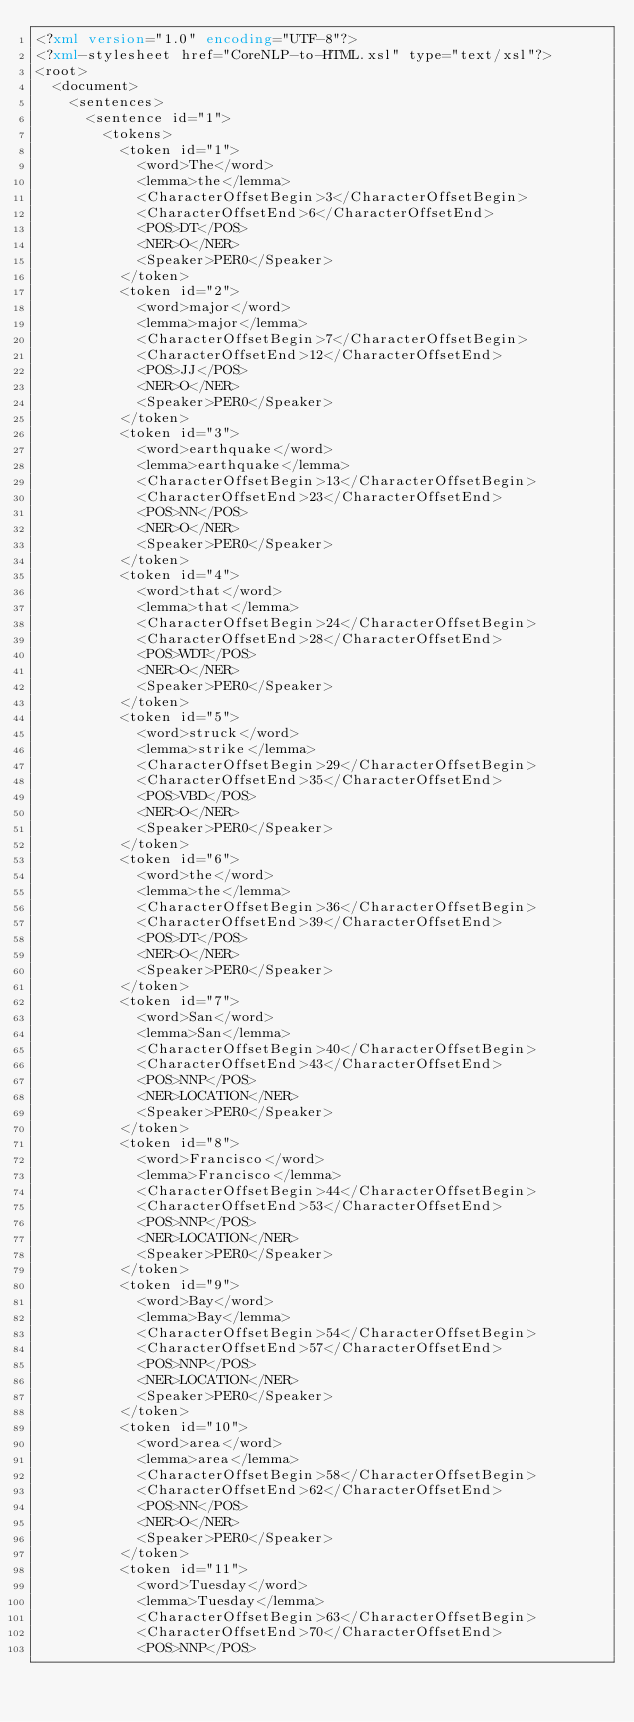<code> <loc_0><loc_0><loc_500><loc_500><_XML_><?xml version="1.0" encoding="UTF-8"?>
<?xml-stylesheet href="CoreNLP-to-HTML.xsl" type="text/xsl"?>
<root>
  <document>
    <sentences>
      <sentence id="1">
        <tokens>
          <token id="1">
            <word>The</word>
            <lemma>the</lemma>
            <CharacterOffsetBegin>3</CharacterOffsetBegin>
            <CharacterOffsetEnd>6</CharacterOffsetEnd>
            <POS>DT</POS>
            <NER>O</NER>
            <Speaker>PER0</Speaker>
          </token>
          <token id="2">
            <word>major</word>
            <lemma>major</lemma>
            <CharacterOffsetBegin>7</CharacterOffsetBegin>
            <CharacterOffsetEnd>12</CharacterOffsetEnd>
            <POS>JJ</POS>
            <NER>O</NER>
            <Speaker>PER0</Speaker>
          </token>
          <token id="3">
            <word>earthquake</word>
            <lemma>earthquake</lemma>
            <CharacterOffsetBegin>13</CharacterOffsetBegin>
            <CharacterOffsetEnd>23</CharacterOffsetEnd>
            <POS>NN</POS>
            <NER>O</NER>
            <Speaker>PER0</Speaker>
          </token>
          <token id="4">
            <word>that</word>
            <lemma>that</lemma>
            <CharacterOffsetBegin>24</CharacterOffsetBegin>
            <CharacterOffsetEnd>28</CharacterOffsetEnd>
            <POS>WDT</POS>
            <NER>O</NER>
            <Speaker>PER0</Speaker>
          </token>
          <token id="5">
            <word>struck</word>
            <lemma>strike</lemma>
            <CharacterOffsetBegin>29</CharacterOffsetBegin>
            <CharacterOffsetEnd>35</CharacterOffsetEnd>
            <POS>VBD</POS>
            <NER>O</NER>
            <Speaker>PER0</Speaker>
          </token>
          <token id="6">
            <word>the</word>
            <lemma>the</lemma>
            <CharacterOffsetBegin>36</CharacterOffsetBegin>
            <CharacterOffsetEnd>39</CharacterOffsetEnd>
            <POS>DT</POS>
            <NER>O</NER>
            <Speaker>PER0</Speaker>
          </token>
          <token id="7">
            <word>San</word>
            <lemma>San</lemma>
            <CharacterOffsetBegin>40</CharacterOffsetBegin>
            <CharacterOffsetEnd>43</CharacterOffsetEnd>
            <POS>NNP</POS>
            <NER>LOCATION</NER>
            <Speaker>PER0</Speaker>
          </token>
          <token id="8">
            <word>Francisco</word>
            <lemma>Francisco</lemma>
            <CharacterOffsetBegin>44</CharacterOffsetBegin>
            <CharacterOffsetEnd>53</CharacterOffsetEnd>
            <POS>NNP</POS>
            <NER>LOCATION</NER>
            <Speaker>PER0</Speaker>
          </token>
          <token id="9">
            <word>Bay</word>
            <lemma>Bay</lemma>
            <CharacterOffsetBegin>54</CharacterOffsetBegin>
            <CharacterOffsetEnd>57</CharacterOffsetEnd>
            <POS>NNP</POS>
            <NER>LOCATION</NER>
            <Speaker>PER0</Speaker>
          </token>
          <token id="10">
            <word>area</word>
            <lemma>area</lemma>
            <CharacterOffsetBegin>58</CharacterOffsetBegin>
            <CharacterOffsetEnd>62</CharacterOffsetEnd>
            <POS>NN</POS>
            <NER>O</NER>
            <Speaker>PER0</Speaker>
          </token>
          <token id="11">
            <word>Tuesday</word>
            <lemma>Tuesday</lemma>
            <CharacterOffsetBegin>63</CharacterOffsetBegin>
            <CharacterOffsetEnd>70</CharacterOffsetEnd>
            <POS>NNP</POS></code> 